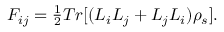Convert formula to latex. <formula><loc_0><loc_0><loc_500><loc_500>\begin{array} { r } { F _ { i j } = \frac { 1 } { 2 } T r [ ( L _ { i } L _ { j } + L _ { j } L _ { i } ) \rho _ { s } ] . } \end{array}</formula> 